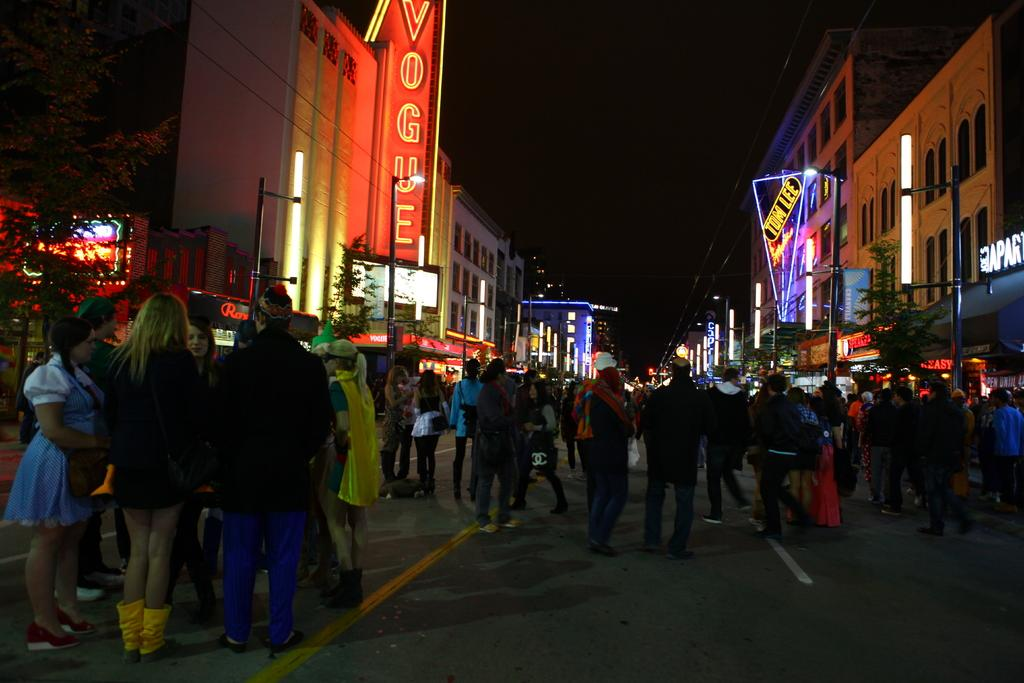What is happening in the image? There is a group of people standing in the image. What can be seen on both sides of the image? There are buildings on the right side and left side of the image. What type of vegetation is present in the image? There are trees in the image. What structures are visible in the image? There are poles and lights in the image. What is at the bottom of the image? There is a road at the bottom of the image. What type of property does the governor own in the image? There is no governor or property mentioned in the image; it features a group of people, buildings, trees, poles, lights, and a road. How does the earthquake affect the buildings in the image? There is no earthquake present in the image; the buildings appear to be standing normally. 